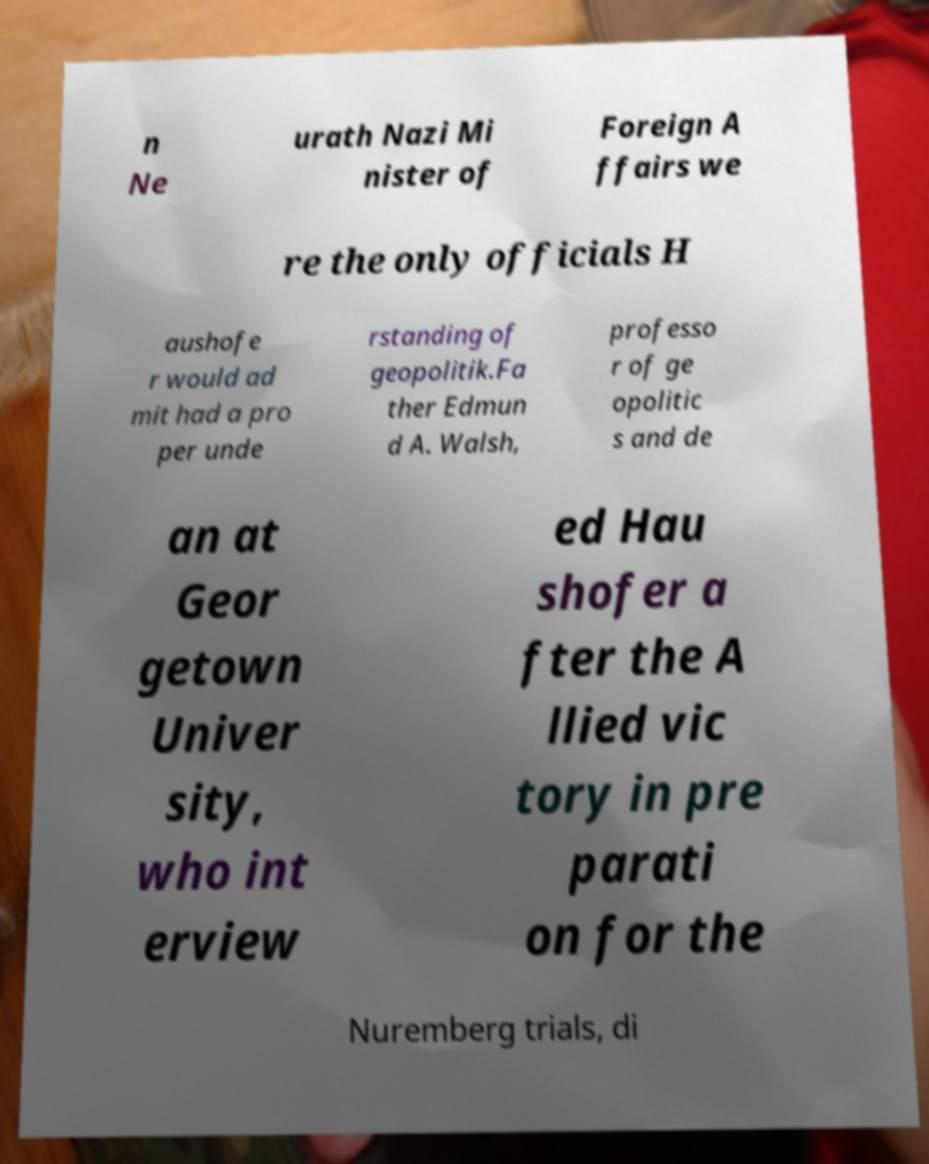For documentation purposes, I need the text within this image transcribed. Could you provide that? n Ne urath Nazi Mi nister of Foreign A ffairs we re the only officials H aushofe r would ad mit had a pro per unde rstanding of geopolitik.Fa ther Edmun d A. Walsh, professo r of ge opolitic s and de an at Geor getown Univer sity, who int erview ed Hau shofer a fter the A llied vic tory in pre parati on for the Nuremberg trials, di 